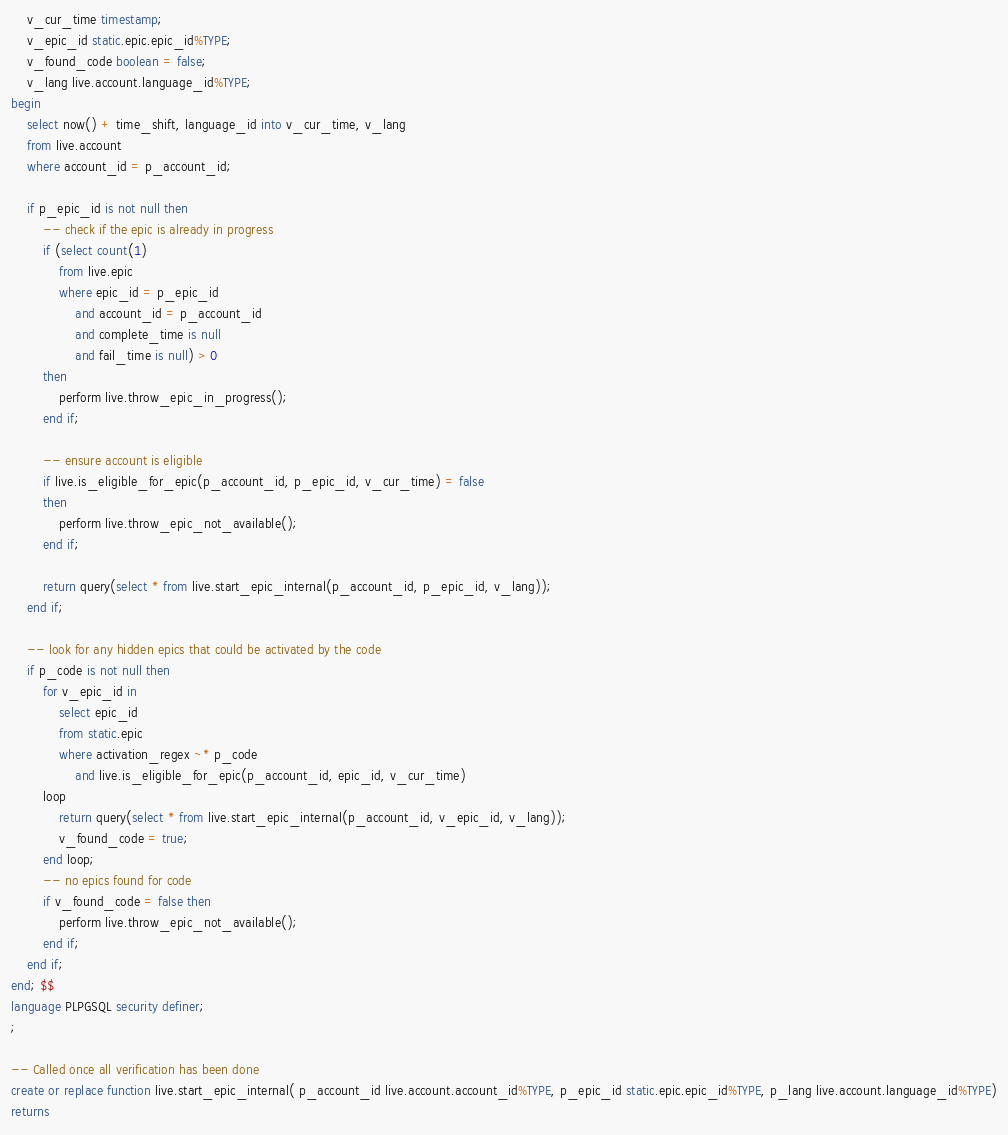Convert code to text. <code><loc_0><loc_0><loc_500><loc_500><_SQL_>	v_cur_time timestamp;
	v_epic_id static.epic.epic_id%TYPE;
	v_found_code boolean = false;
	v_lang live.account.language_id%TYPE;
begin
	select now() + time_shift, language_id into v_cur_time, v_lang
	from live.account
	where account_id = p_account_id;

	if p_epic_id is not null then
		-- check if the epic is already in progress
		if (select count(1)
			from live.epic
			where epic_id = p_epic_id
				and account_id = p_account_id
				and complete_time is null
				and fail_time is null) > 0
		then
			perform live.throw_epic_in_progress();
		end if;

		-- ensure account is eligible
		if live.is_eligible_for_epic(p_account_id, p_epic_id, v_cur_time) = false 
		then
			perform live.throw_epic_not_available();
		end if;

		return query(select * from live.start_epic_internal(p_account_id, p_epic_id, v_lang));
	end if;

	-- look for any hidden epics that could be activated by the code
	if p_code is not null then
		for v_epic_id in 
			select epic_id 
			from static.epic 
			where activation_regex ~* p_code
				and live.is_eligible_for_epic(p_account_id, epic_id, v_cur_time)
		loop
			return query(select * from live.start_epic_internal(p_account_id, v_epic_id, v_lang));
			v_found_code = true;
		end loop;
		-- no epics found for code
		if v_found_code = false then
			perform live.throw_epic_not_available();
		end if;
	end if;
end; $$
language PLPGSQL security definer;
;

-- Called once all verification has been done
create or replace function live.start_epic_internal( p_account_id live.account.account_id%TYPE, p_epic_id static.epic.epic_id%TYPE, p_lang live.account.language_id%TYPE)
returns </code> 